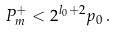Convert formula to latex. <formula><loc_0><loc_0><loc_500><loc_500>P _ { m } ^ { + } < 2 ^ { l _ { 0 } + 2 } p _ { 0 } \, .</formula> 